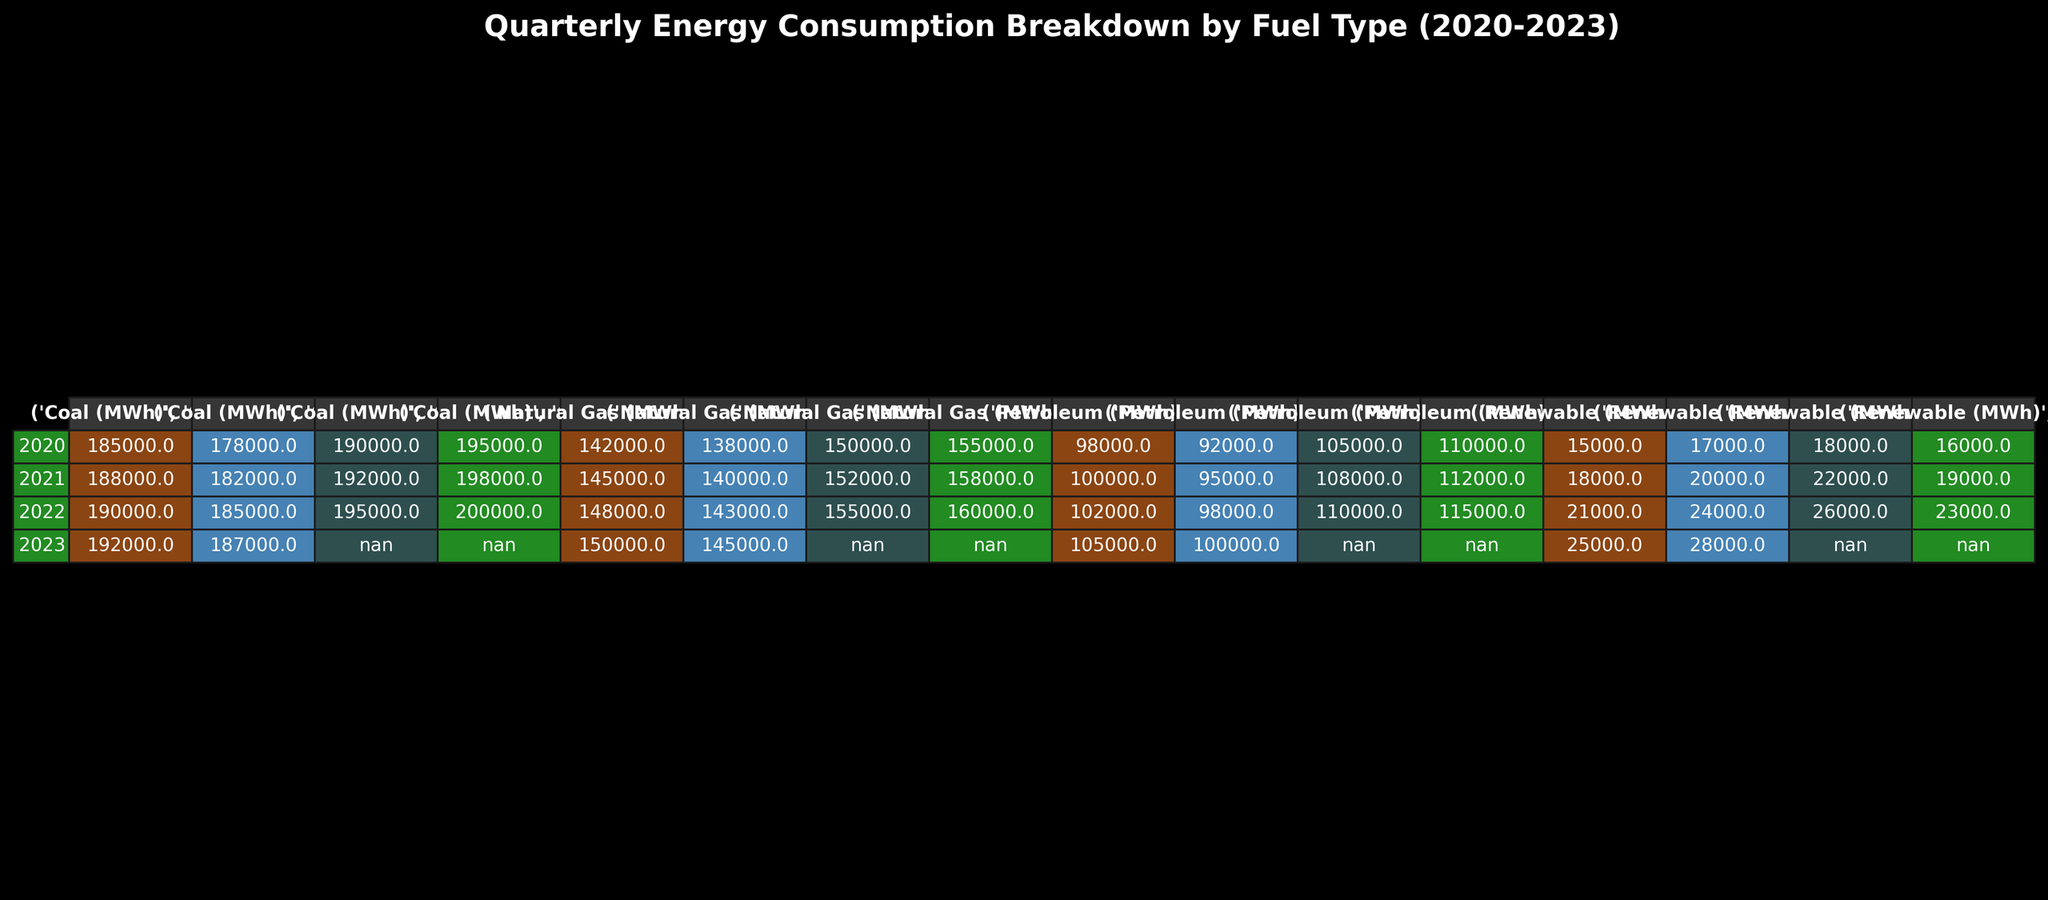What was the total coal consumption in 2020? To find the total coal consumption for 2020, sum the coal consumption values from each quarter: 185000 + 178000 + 190000 + 195000 = 746000 MWh.
Answer: 746000 MWh Which quarter had the highest petroleum consumption in 2022? Looking at the petroleum consumption data for 2022, the values are: Q1 = 102000, Q2 = 98000, Q3 = 110000, Q4 = 115000. The highest value is in Q4 with 115000 MWh.
Answer: Q4 What is the average natural gas consumption across all quarters in 2021? For 2021, the natural gas consumption values are: Q1 = 145000, Q2 = 140000, Q3 = 152000, Q4 = 158000. Adding these: 145000 + 140000 + 152000 + 158000 = 595000 MWh. The average is 595000 / 4 = 148750 MWh.
Answer: 148750 MWh Did renewable energy consumption increase or decrease from Q1 2020 to Q2 2023? Compare the renewable energy values: Q1 2020 = 15000 MWh and Q2 2023 = 28000 MWh. Since 28000 > 15000, it increased.
Answer: Increased What was the percentage increase in coal consumption from Q1 2020 to Q4 2023? Coal consumption in Q1 2020 is 185000 MWh, and in Q2 2023 it is 187000 MWh. The increase is 187000 - 185000 = 2000 MWh. The percentage increase is (2000 / 185000) * 100 ≈ 1.08%.
Answer: 1.08% In which year did natural gas consumption peak, and what was the total for that year? Checking each year's total: 2020 = 605000 MWh, 2021 = 598000 MWh, 2022 = 606000 MWh, and 2023 = 295000 MWh. The peak is in 2022 with 606000 MWh.
Answer: 2022, 606000 MWh Calculate the total consumption of all fuel types in Q3 2021. In Q3 2021, the values are: Coal = 192000 MWh, Natural Gas = 152000 MWh, Petroleum = 108000 MWh, Renewable = 22000 MWh. Total = 192000 + 152000 + 108000 + 22000 = 474000 MWh.
Answer: 474000 MWh Is it true that petroleum consumption was higher in Q3 than in Q4 for all years? Check each year: 2020 (Q3 = 105000, Q4 = 110000), 2021 (Q3 = 108000, Q4 = 112000), 2022 (Q3 = 110000, Q4 = 115000), 2023 (Q1 = 105000, Q2 = 100000). Not true as in all years Q4 had higher values.
Answer: False What are the total renewable energy contributions for all quarters in 2020 and 2021 combined? The renewable energy values for 2020 are: Q1 = 15000, Q2 = 17000, Q3 = 18000, Q4 = 16000. The total for 2020 is 15000 + 17000 + 18000 + 16000 = 66000 MWh. For 2021: Q1 = 18000, Q2 = 20000, Q3 = 22000, Q4 = 19000; total for 2021 is 18000 + 20000 + 22000 + 19000 = 79000 MWh. Combined total = 66000 + 79000 = 145000 MWh.
Answer: 145000 MWh What is the average quarterly renewable energy consumption for the entire dataset? For all quarters: Add all renewable values (15000 + 17000 + 18000 + 16000 + 18000 + 20000 + 22000 + 19000 + 21000 + 24000 + 26000 + 23000 + 25000 + 28000) = 307000 MWh. There are 14 quarters, so the average is 307000 / 14 ≈ 21928.57 MWh.
Answer: 21928.57 MWh 